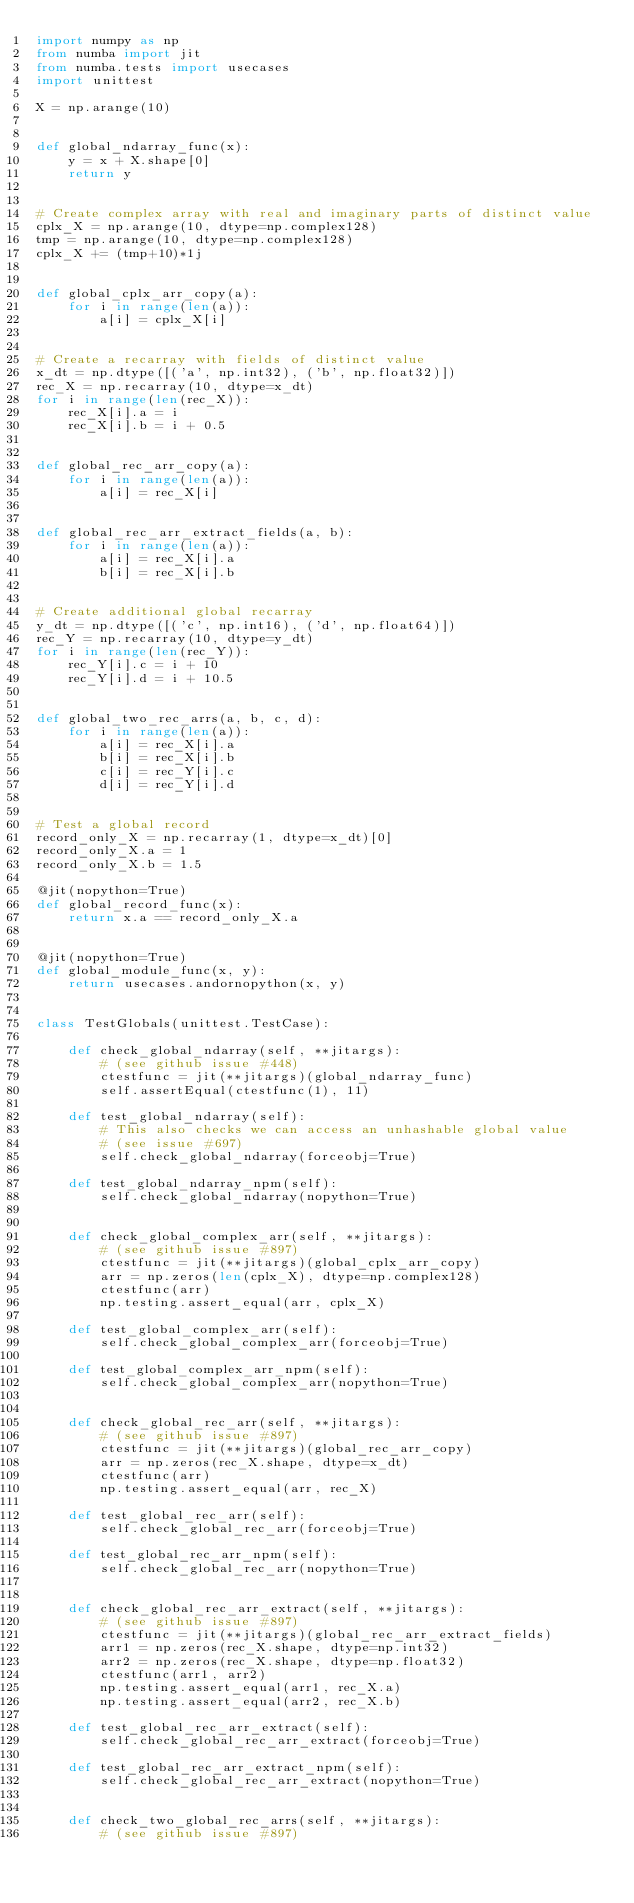<code> <loc_0><loc_0><loc_500><loc_500><_Python_>import numpy as np
from numba import jit
from numba.tests import usecases
import unittest

X = np.arange(10)


def global_ndarray_func(x):
    y = x + X.shape[0]
    return y


# Create complex array with real and imaginary parts of distinct value
cplx_X = np.arange(10, dtype=np.complex128)
tmp = np.arange(10, dtype=np.complex128)
cplx_X += (tmp+10)*1j


def global_cplx_arr_copy(a):
    for i in range(len(a)):
        a[i] = cplx_X[i]


# Create a recarray with fields of distinct value
x_dt = np.dtype([('a', np.int32), ('b', np.float32)])
rec_X = np.recarray(10, dtype=x_dt)
for i in range(len(rec_X)):
    rec_X[i].a = i
    rec_X[i].b = i + 0.5


def global_rec_arr_copy(a):
    for i in range(len(a)):
        a[i] = rec_X[i]


def global_rec_arr_extract_fields(a, b):
    for i in range(len(a)):
        a[i] = rec_X[i].a
        b[i] = rec_X[i].b


# Create additional global recarray
y_dt = np.dtype([('c', np.int16), ('d', np.float64)])
rec_Y = np.recarray(10, dtype=y_dt)
for i in range(len(rec_Y)):
    rec_Y[i].c = i + 10
    rec_Y[i].d = i + 10.5


def global_two_rec_arrs(a, b, c, d):
    for i in range(len(a)):
        a[i] = rec_X[i].a
        b[i] = rec_X[i].b
        c[i] = rec_Y[i].c
        d[i] = rec_Y[i].d


# Test a global record
record_only_X = np.recarray(1, dtype=x_dt)[0]
record_only_X.a = 1
record_only_X.b = 1.5

@jit(nopython=True)
def global_record_func(x):
    return x.a == record_only_X.a


@jit(nopython=True)
def global_module_func(x, y):
    return usecases.andornopython(x, y)


class TestGlobals(unittest.TestCase):

    def check_global_ndarray(self, **jitargs):
        # (see github issue #448)
        ctestfunc = jit(**jitargs)(global_ndarray_func)
        self.assertEqual(ctestfunc(1), 11)

    def test_global_ndarray(self):
        # This also checks we can access an unhashable global value
        # (see issue #697)
        self.check_global_ndarray(forceobj=True)

    def test_global_ndarray_npm(self):
        self.check_global_ndarray(nopython=True)


    def check_global_complex_arr(self, **jitargs):
        # (see github issue #897)
        ctestfunc = jit(**jitargs)(global_cplx_arr_copy)
        arr = np.zeros(len(cplx_X), dtype=np.complex128)
        ctestfunc(arr)
        np.testing.assert_equal(arr, cplx_X)

    def test_global_complex_arr(self):
        self.check_global_complex_arr(forceobj=True)

    def test_global_complex_arr_npm(self):
        self.check_global_complex_arr(nopython=True)


    def check_global_rec_arr(self, **jitargs):
        # (see github issue #897)
        ctestfunc = jit(**jitargs)(global_rec_arr_copy)
        arr = np.zeros(rec_X.shape, dtype=x_dt)
        ctestfunc(arr)
        np.testing.assert_equal(arr, rec_X)

    def test_global_rec_arr(self):
        self.check_global_rec_arr(forceobj=True)

    def test_global_rec_arr_npm(self):
        self.check_global_rec_arr(nopython=True)


    def check_global_rec_arr_extract(self, **jitargs):
        # (see github issue #897)
        ctestfunc = jit(**jitargs)(global_rec_arr_extract_fields)
        arr1 = np.zeros(rec_X.shape, dtype=np.int32)
        arr2 = np.zeros(rec_X.shape, dtype=np.float32)
        ctestfunc(arr1, arr2)
        np.testing.assert_equal(arr1, rec_X.a)
        np.testing.assert_equal(arr2, rec_X.b)

    def test_global_rec_arr_extract(self):
        self.check_global_rec_arr_extract(forceobj=True)

    def test_global_rec_arr_extract_npm(self):
        self.check_global_rec_arr_extract(nopython=True)


    def check_two_global_rec_arrs(self, **jitargs):
        # (see github issue #897)</code> 